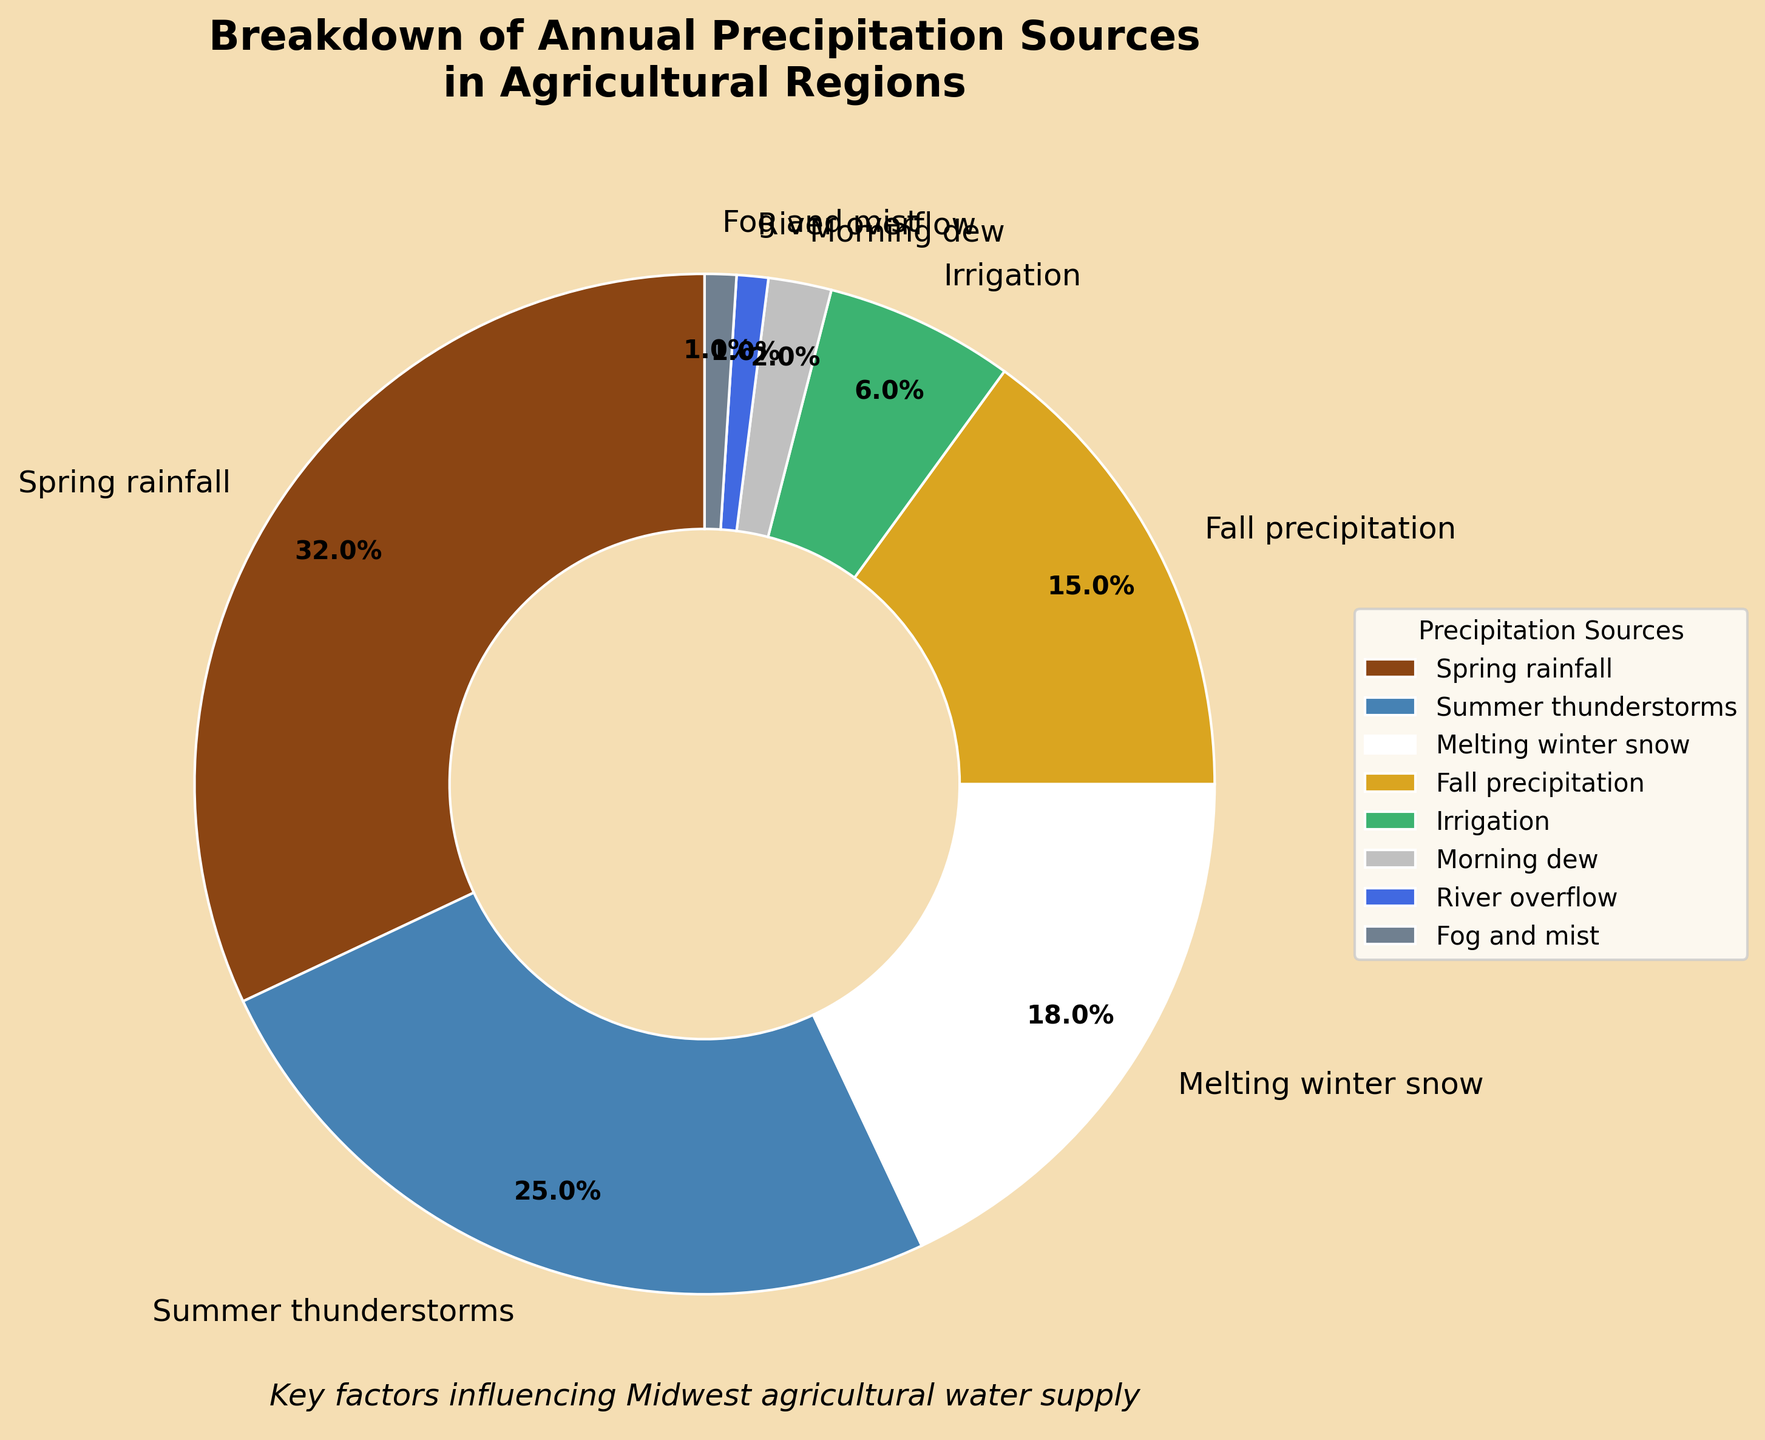Which source contributes the most to annual precipitation? The largest wedge in the pie chart represents Spring rainfall, which is 32%.
Answer: Spring rainfall What is the combined percentage of summer thunderstorms and fall precipitation? Summer thunderstorms contribute 25% and fall precipitation contributes 15%. Adding these together, 25% + 15% = 40%.
Answer: 40% How much more does spring rainfall contribute compared to irrigation? Spring rainfall contributes 32%, while irrigation contributes 6%. The difference is 32% - 6% = 26%.
Answer: 26% Rank the top three sources of annual precipitation from highest to lowest. The pie chart shows: 1) Spring rainfall (32%), 2) Summer thunderstorms (25%), 3) Melting winter snow (18%).
Answer: Spring rainfall, Summer thunderstorms, Melting winter snow Which source has the smallest contribution to annual precipitation? The smallest wedge represents Fog and mist, which is 1%.
Answer: Fog and mist What is the percentage of sources contributing less than 10% combined? Irrigation (6%), Morning dew (2%), River overflow (1%), and Fog and mist (1%) each contribute less than 10%. Combined, 6% + 2% + 1% + 1% = 10%.
Answer: 10% Is fall precipitation more or less than melting winter snow? By what percentage? Fall precipitation is 15%, while melting winter snow is 18%. The difference is 18% - 15% = 3%.
Answer: Less, by 3% Compare the contribution of river overflow to morning dew. River overflow contributes 1%, while morning dew contributes 2%. Thus, morning dew contributes more than river overflow.
Answer: Morning dew contributes more What percent of the annual precipitation is from non-rainfall sources (i.e., excluding spring rainfall and summer thunderstorms)? Excluding the two largest sources: Spring rainfall (32%) and Summer thunderstorms (25%). The remaining sources add up to: 18% (Melting winter snow) + 15% (Fall precipitation) + 6 (Irrigation) + 2 (Morning dew) + 1 (River overflow) + 1 (Fog and mist) = 43%.
Answer: 43% How do the contributions of melting winter snow and irrigation compare? Melting winter snow contributes 18%, while irrigation contributes 6%. Melting winter snow contributes 3 times as much as irrigation.
Answer: Melting winter snow contributes 3 times as much 